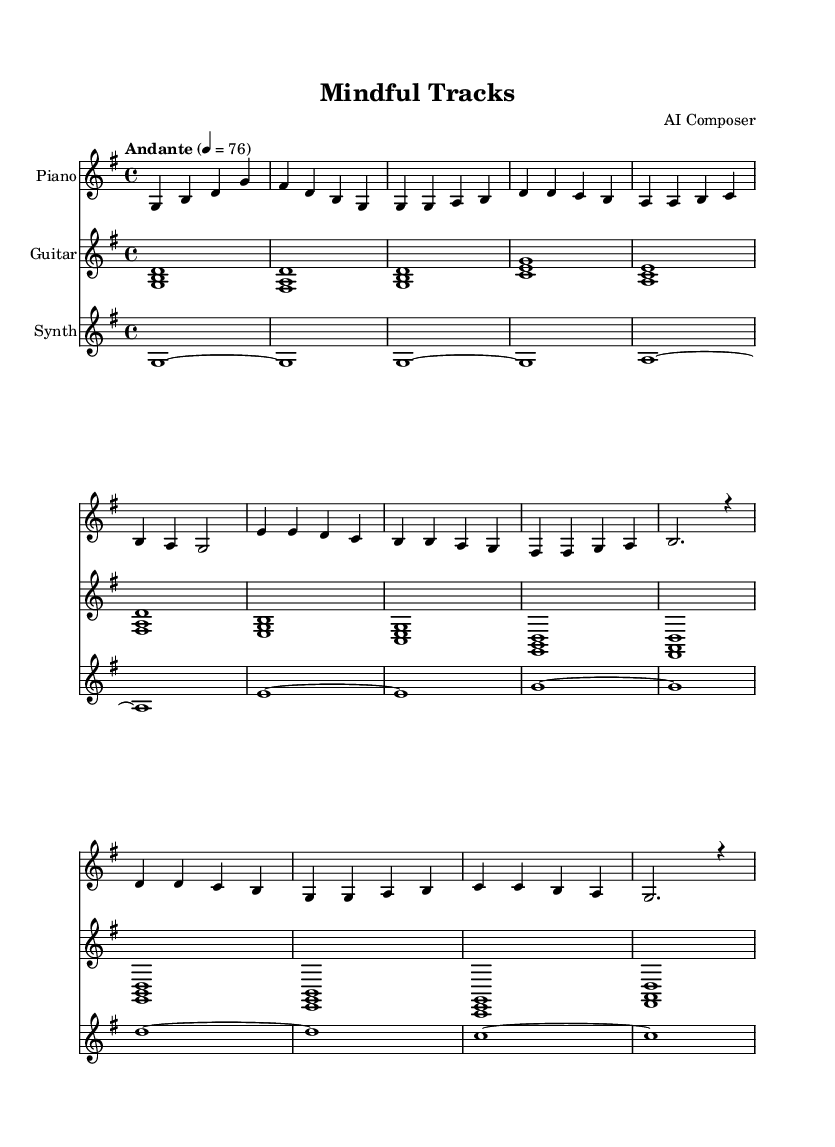What is the key signature of this music? The key signature is G major, indicated by one sharp (F#). It can be identified at the beginning of the staff after the clef.
Answer: G major What is the time signature of this music? The time signature is 4/4, which means there are four beats per measure and the quarter note gets one beat. This is observed after the clef and key signature.
Answer: 4/4 What is the tempo marking of this music? The tempo marking is "Andante," indicating a moderate pace, and it is followed by a metronome marking of 76 beats per minute. This is noted above the staff.
Answer: Andante How many measures are in the piano part? The piano part contains 16 measures in total, which can be counted by looking at the vertical lines that denote the end of each measure.
Answer: 16 What is the starting note of the synth part? The starting note of the synth part is G. This can be determined by looking at the first note in the synth staff, which is a G in the bass clef.
Answer: G What is the highest note played in the guitar part? The highest note in the guitar part is A, which can be seen in measure 5 of the guitar staff where the chord <a c e> contains an A note.
Answer: A How many different instruments are used in this piece? There are three different instruments used: Piano, Guitar, and Synth. This can be confirmed by the three distinct staffs at the beginning of the score, each labeled with an instrument name.
Answer: Three 